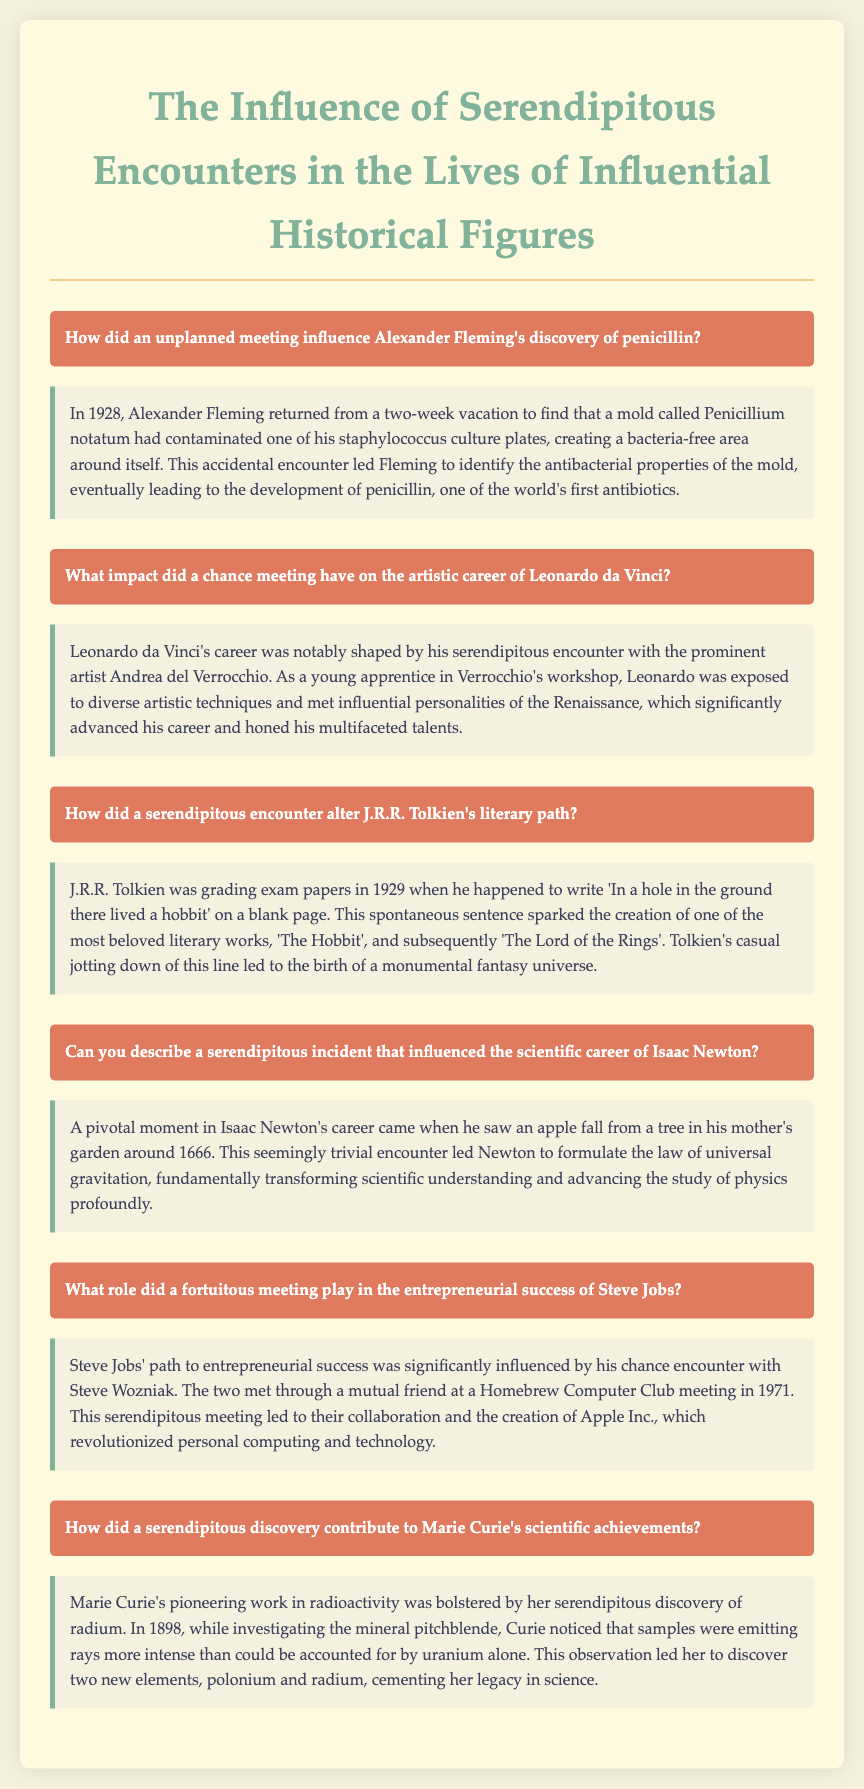How did an unplanned meeting influence Alexander Fleming's discovery of penicillin? The document provides a specific example of an unplanned meeting leading to Fleming's discovery of penicillin in 1928.
Answer: 1928 What was the role of Leonardo da Vinci's encounter with Andrea del Verrocchio? The document describes how this encounter significantly advanced Leonardo's career and honed his talents.
Answer: Advanced his career In what year did J.R.R. Tolkien write the famous line that started his literary journey? The document states that Tolkien wrote 'In a hole in the ground there lived a hobbit' in 1929.
Answer: 1929 What observation led Isaac Newton to formulate the law of universal gravitation? The document mentions that Newton's observation of an apple falling from a tree was pivotal in formulating his law.
Answer: Apple falling Who significantly impacted Steve Jobs' path to success? The document highlights Steve Wozniak as the influential figure Jobs met through a mutual friend.
Answer: Steve Wozniak What mineral did Marie Curie investigate that led to her discovery of radium? The document notes that Curie was investigating pitchblende when she made her discovery.
Answer: Pitchblende 